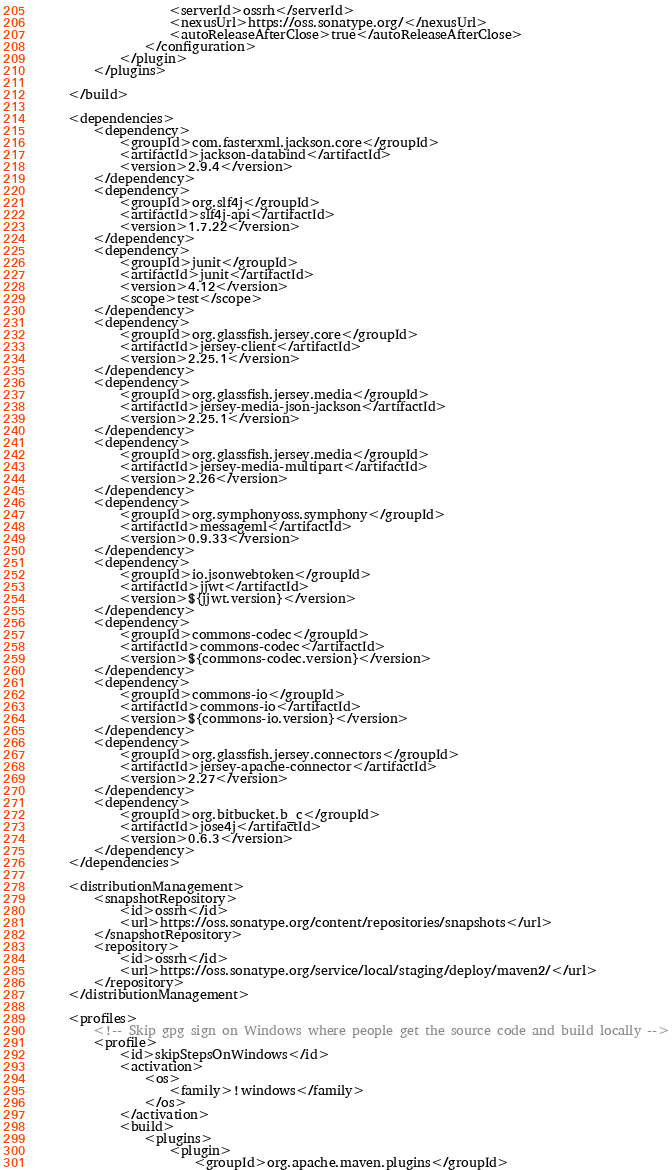<code> <loc_0><loc_0><loc_500><loc_500><_XML_>                    <serverId>ossrh</serverId>
                    <nexusUrl>https://oss.sonatype.org/</nexusUrl>
                    <autoReleaseAfterClose>true</autoReleaseAfterClose>
                </configuration>
            </plugin>
        </plugins>

    </build>

    <dependencies>
        <dependency>
            <groupId>com.fasterxml.jackson.core</groupId>
            <artifactId>jackson-databind</artifactId>
            <version>2.9.4</version>
        </dependency>
        <dependency>
            <groupId>org.slf4j</groupId>
            <artifactId>slf4j-api</artifactId>
            <version>1.7.22</version>
        </dependency>
        <dependency>
            <groupId>junit</groupId>
            <artifactId>junit</artifactId>
            <version>4.12</version>
            <scope>test</scope>
        </dependency>
        <dependency>
            <groupId>org.glassfish.jersey.core</groupId>
            <artifactId>jersey-client</artifactId>
            <version>2.25.1</version>
        </dependency>
        <dependency>
            <groupId>org.glassfish.jersey.media</groupId>
            <artifactId>jersey-media-json-jackson</artifactId>
            <version>2.25.1</version>
        </dependency>
        <dependency>
            <groupId>org.glassfish.jersey.media</groupId>
            <artifactId>jersey-media-multipart</artifactId>
            <version>2.26</version>
        </dependency>
        <dependency>
            <groupId>org.symphonyoss.symphony</groupId>
            <artifactId>messageml</artifactId>
            <version>0.9.33</version>
        </dependency>
        <dependency>
            <groupId>io.jsonwebtoken</groupId>
            <artifactId>jjwt</artifactId>
            <version>${jjwt.version}</version>
        </dependency>
        <dependency>
            <groupId>commons-codec</groupId>
            <artifactId>commons-codec</artifactId>
            <version>${commons-codec.version}</version>
        </dependency>
        <dependency>
            <groupId>commons-io</groupId>
            <artifactId>commons-io</artifactId>
            <version>${commons-io.version}</version>
        </dependency>
        <dependency>
            <groupId>org.glassfish.jersey.connectors</groupId>
            <artifactId>jersey-apache-connector</artifactId>
            <version>2.27</version>
        </dependency>
        <dependency>
            <groupId>org.bitbucket.b_c</groupId>
            <artifactId>jose4j</artifactId>
            <version>0.6.3</version>
        </dependency>
    </dependencies>

    <distributionManagement>
        <snapshotRepository>
            <id>ossrh</id>
            <url>https://oss.sonatype.org/content/repositories/snapshots</url>
        </snapshotRepository>
        <repository>
            <id>ossrh</id>
            <url>https://oss.sonatype.org/service/local/staging/deploy/maven2/</url>
        </repository>
    </distributionManagement>

    <profiles>
        <!-- Skip gpg sign on Windows where people get the source code and build locally -->
        <profile>
            <id>skipStepsOnWindows</id>
            <activation>
                <os>
                    <family>!windows</family>
                </os>
            </activation>
            <build>
                <plugins>
                    <plugin>
                        <groupId>org.apache.maven.plugins</groupId></code> 